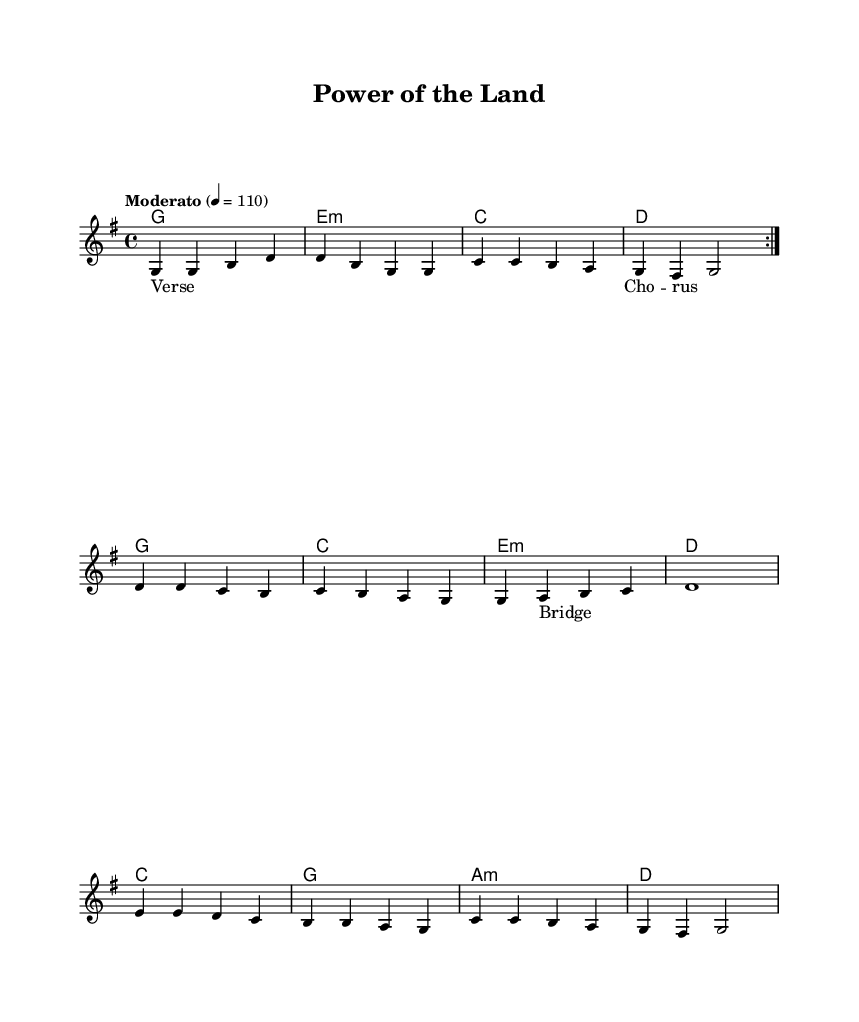What is the key signature of this music? The key signature is G major, indicated by one sharp (F#) at the beginning of the staff.
Answer: G major What is the time signature of the piece? The time signature is 4/4, shown at the beginning of the staff and indicates four beats per measure.
Answer: 4/4 What is the tempo marking for this piece? The tempo marking is "Moderato," which is indicated at the beginning of the score and suggests a moderate speed.
Answer: Moderato How many measures are in the first volta of the melody? The first volta of the melody consists of four measures, as shown in the repeated section denoted by the volta markings.
Answer: Four What is the total number of chords used in the harmonies section? There are a total of 10 chords in the harmonies section; they are presented in a sequence that comprises 10 separate instances of harmonic changes.
Answer: Ten Which lyric section suggests a shift in the song structure? The "Bridge" section suggests a shift in the song structure, as it typically represents a contrasting idea or theme within folk music.
Answer: Bridge What type of song is this based on its themes? This song can be categorized as a contemporary folk anthem due to its focus on themes of renewable energy and sustainability.
Answer: Folk anthem 